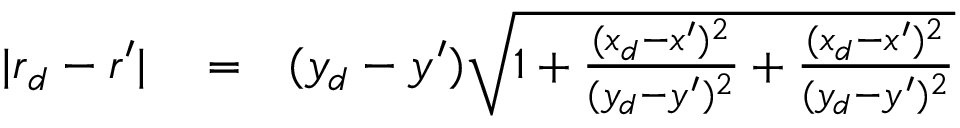Convert formula to latex. <formula><loc_0><loc_0><loc_500><loc_500>\begin{array} { r l r } { | r _ { d } - r ^ { \prime } | } & = } & { ( y _ { d } - y ^ { \prime } ) \sqrt { 1 + \frac { ( x _ { d } - x ^ { \prime } ) ^ { 2 } } { ( y _ { d } - y ^ { \prime } ) ^ { 2 } } + \frac { ( x _ { d } - x ^ { \prime } ) ^ { 2 } } { ( y _ { d } - y ^ { \prime } ) ^ { 2 } } } } \end{array}</formula> 